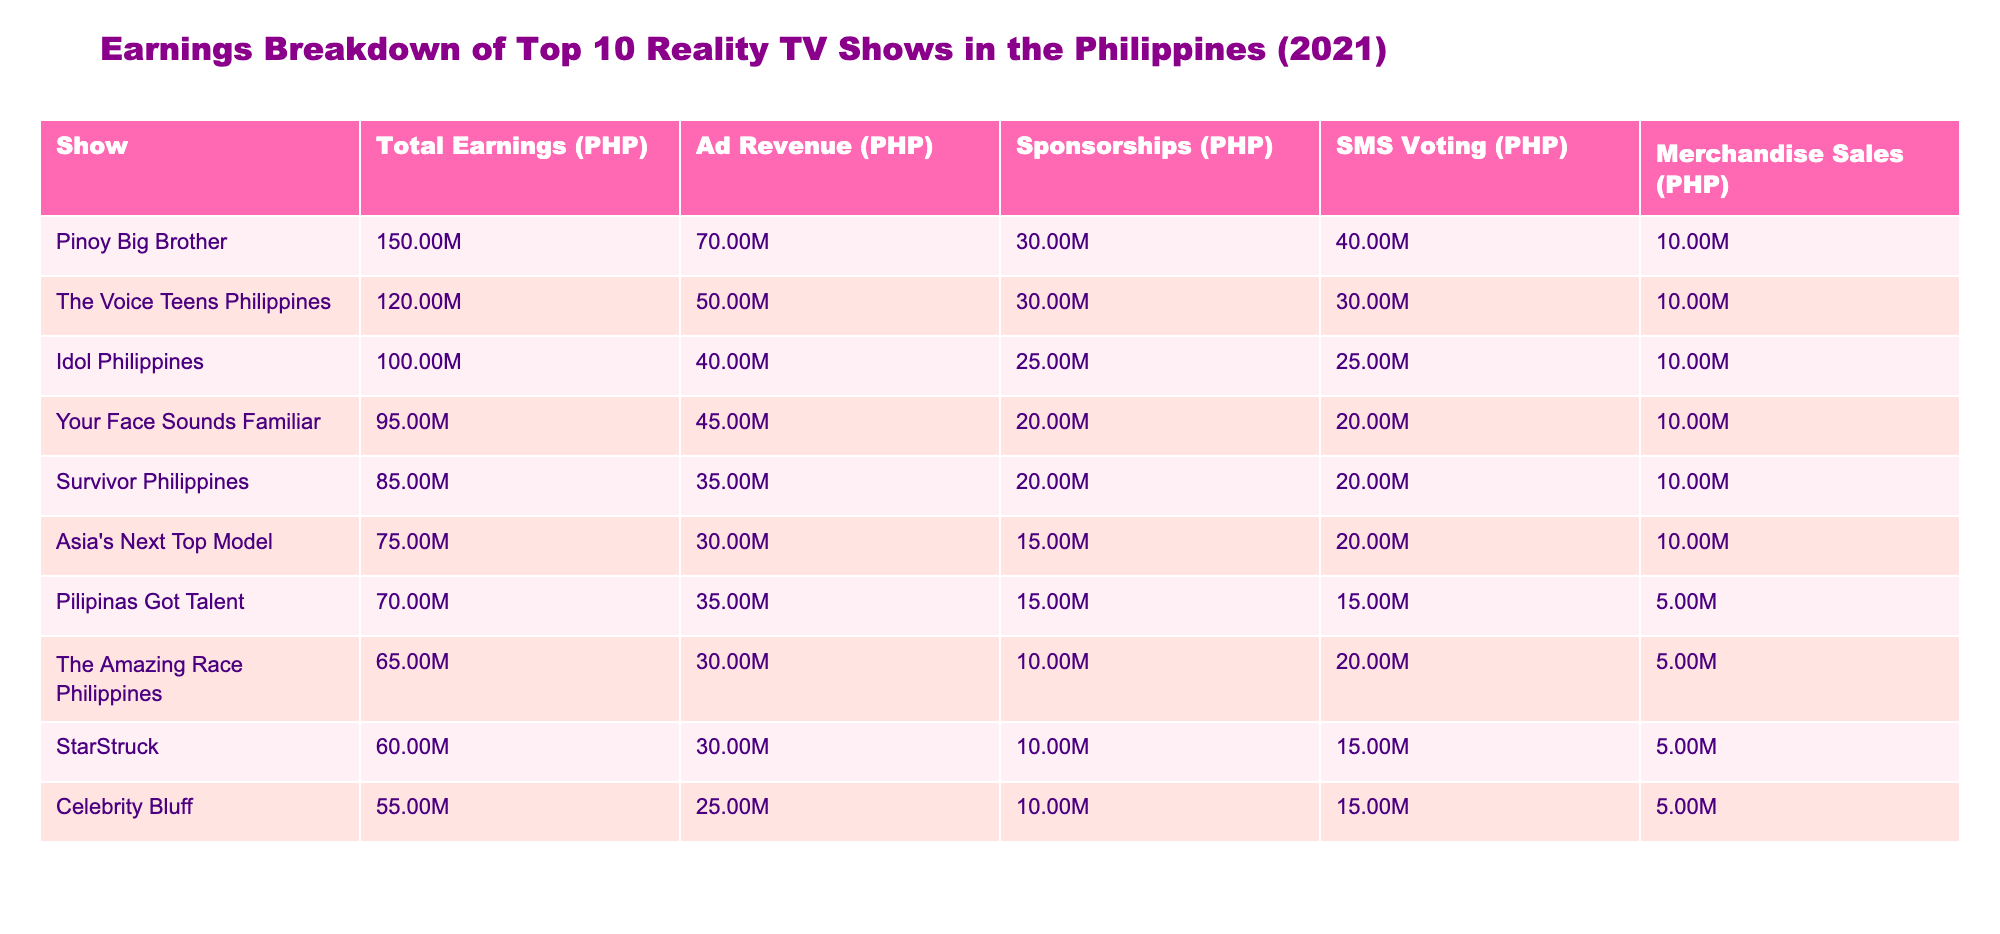What is the total earnings of "Pinoy Big Brother"? The table shows that "Pinoy Big Brother" has total earnings of 150,000,000 PHP.
Answer: 150,000,000 PHP Which show has the highest SMS voting earnings? "Pinoy Big Brother" has the highest SMS voting earnings of 40,000,000 PHP among all shows listed.
Answer: Pinoy Big Brother What is the total earnings of the bottom three shows combined? The bottom three shows are "StarStruck", "Celebrity Bluff", and "The Amazing Race Philippines", with earnings of 60,000,000 PHP, 55,000,000 PHP, and 65,000,000 PHP respectively. Their combined total is 60 + 55 + 65 = 180 million PHP.
Answer: 180,000,000 PHP Is "Asia's Next Top Model" earning more from merchandise sales than "Pilipinas Got Talent"? The table shows that "Asia's Next Top Model" earns 10,000,000 PHP from merchandise sales while "Pilipinas Got Talent" earns 5,000,000 PHP. Thus, yes, it earns more.
Answer: Yes What percentage of the total earnings does "The Voice Teens Philippines" earn from ad revenue? "The Voice Teens Philippines" has total earnings of 120,000,000 PHP with ad revenue of 50,000,000 PHP. To find the percentage, calculate (50,000,000 / 120,000,000) * 100 = 41.67%.
Answer: 41.67% Which show has the lowest earnings from sponsorships? Checking the sponsorships column, "Celebrity Bluff" has the lowest earnings from sponsorships at 10,000,000 PHP.
Answer: Celebrity Bluff What is the average total earnings of the top three shows? The total earnings for the top three shows are "Pinoy Big Brother" (150,000,000 PHP), "The Voice Teens Philippines" (120,000,000 PHP), and "Idol Philippines" (100,000,000 PHP). Their average is (150 + 120 + 100) / 3 = 123.33 million PHP.
Answer: 123,333,333 PHP How much more does "Your Face Sounds Familiar" earn from ad revenue compared to "Survivor Philippines"? "Your Face Sounds Familiar" earns 45,000,000 PHP from ad revenue, and "Survivor Philippines" earns 35,000,000 PHP. The difference is 45,000,000 - 35,000,000 = 10,000,000 PHP.
Answer: 10,000,000 PHP Does "The Amazing Race Philippines" have a total earning that is greater than 70 million PHP? The table lists total earnings for "The Amazing Race Philippines" as 65,000,000 PHP, which is less than 70 million PHP.
Answer: No 